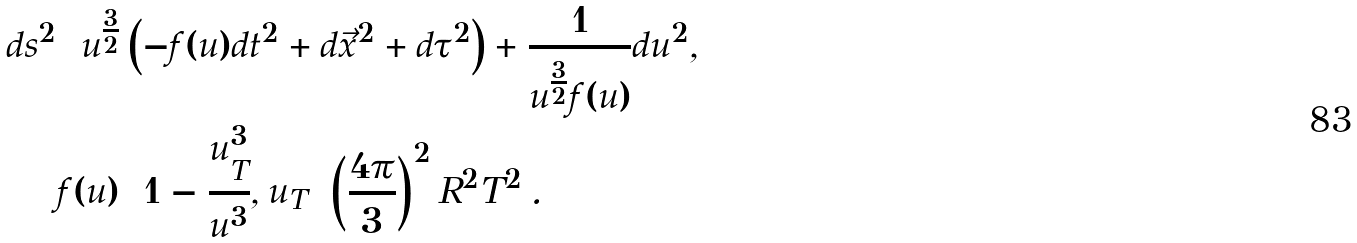Convert formula to latex. <formula><loc_0><loc_0><loc_500><loc_500>d s ^ { 2 } & = u ^ { \frac { 3 } { 2 } } \left ( - f ( u ) d t ^ { 2 } + d \vec { x } ^ { 2 } + d \tau ^ { 2 } \right ) + \frac { 1 } { u ^ { \frac { 3 } { 2 } } f ( u ) } d u ^ { 2 } , \\ & f ( u ) = 1 - \frac { u _ { T } ^ { 3 } } { u ^ { 3 } } , u _ { T } = \left ( \frac { 4 \pi } 3 \right ) ^ { 2 } R ^ { 2 } T ^ { 2 } \, .</formula> 